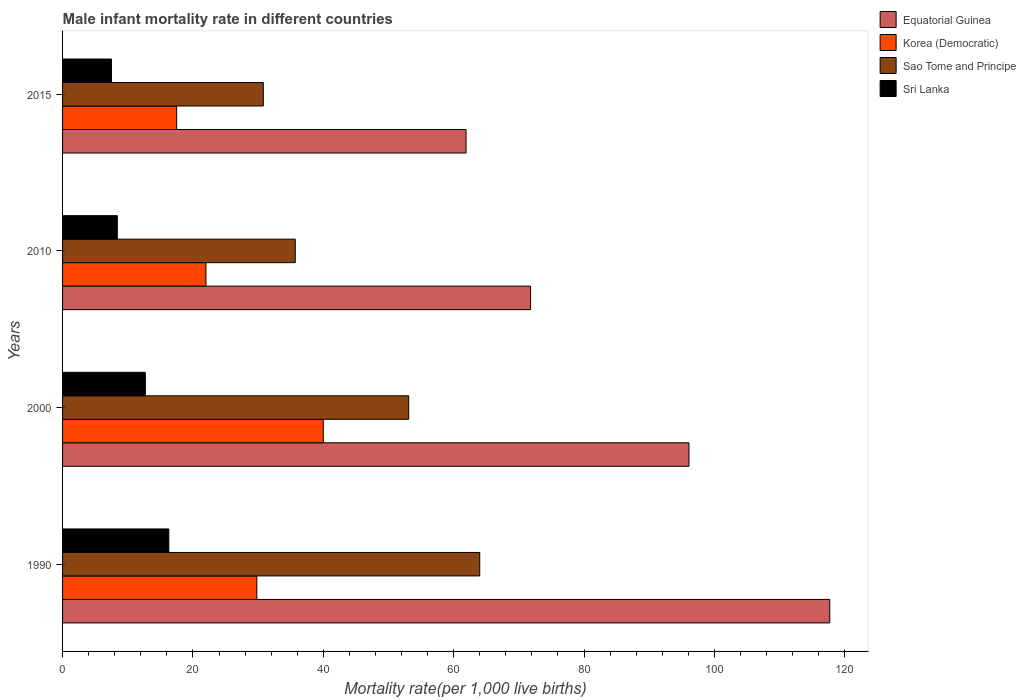How many different coloured bars are there?
Make the answer very short. 4. How many bars are there on the 3rd tick from the top?
Provide a short and direct response. 4. What is the label of the 4th group of bars from the top?
Provide a short and direct response. 1990. In how many cases, is the number of bars for a given year not equal to the number of legend labels?
Offer a terse response. 0. What is the male infant mortality rate in Equatorial Guinea in 2000?
Provide a short and direct response. 96.1. Across all years, what is the maximum male infant mortality rate in Equatorial Guinea?
Ensure brevity in your answer.  117.7. Across all years, what is the minimum male infant mortality rate in Sri Lanka?
Your response must be concise. 7.5. In which year was the male infant mortality rate in Sao Tome and Principe maximum?
Your response must be concise. 1990. In which year was the male infant mortality rate in Equatorial Guinea minimum?
Keep it short and to the point. 2015. What is the total male infant mortality rate in Sao Tome and Principe in the graph?
Offer a very short reply. 183.6. What is the difference between the male infant mortality rate in Korea (Democratic) in 2000 and that in 2015?
Keep it short and to the point. 22.5. What is the difference between the male infant mortality rate in Equatorial Guinea in 2010 and the male infant mortality rate in Sri Lanka in 2000?
Offer a very short reply. 59.1. What is the average male infant mortality rate in Sao Tome and Principe per year?
Ensure brevity in your answer.  45.9. In the year 2000, what is the difference between the male infant mortality rate in Sri Lanka and male infant mortality rate in Equatorial Guinea?
Keep it short and to the point. -83.4. What is the ratio of the male infant mortality rate in Sao Tome and Principe in 2000 to that in 2010?
Provide a short and direct response. 1.49. What is the difference between the highest and the second highest male infant mortality rate in Sri Lanka?
Offer a terse response. 3.6. What is the difference between the highest and the lowest male infant mortality rate in Equatorial Guinea?
Keep it short and to the point. 55.8. In how many years, is the male infant mortality rate in Korea (Democratic) greater than the average male infant mortality rate in Korea (Democratic) taken over all years?
Make the answer very short. 2. What does the 1st bar from the top in 2010 represents?
Provide a succinct answer. Sri Lanka. What does the 1st bar from the bottom in 2000 represents?
Provide a short and direct response. Equatorial Guinea. Is it the case that in every year, the sum of the male infant mortality rate in Sao Tome and Principe and male infant mortality rate in Equatorial Guinea is greater than the male infant mortality rate in Korea (Democratic)?
Offer a very short reply. Yes. Are all the bars in the graph horizontal?
Give a very brief answer. Yes. What is the difference between two consecutive major ticks on the X-axis?
Provide a succinct answer. 20. Are the values on the major ticks of X-axis written in scientific E-notation?
Make the answer very short. No. Does the graph contain any zero values?
Offer a terse response. No. Does the graph contain grids?
Offer a very short reply. No. How many legend labels are there?
Keep it short and to the point. 4. How are the legend labels stacked?
Your response must be concise. Vertical. What is the title of the graph?
Offer a very short reply. Male infant mortality rate in different countries. Does "Estonia" appear as one of the legend labels in the graph?
Your answer should be compact. No. What is the label or title of the X-axis?
Keep it short and to the point. Mortality rate(per 1,0 live births). What is the label or title of the Y-axis?
Offer a terse response. Years. What is the Mortality rate(per 1,000 live births) in Equatorial Guinea in 1990?
Keep it short and to the point. 117.7. What is the Mortality rate(per 1,000 live births) in Korea (Democratic) in 1990?
Provide a short and direct response. 29.8. What is the Mortality rate(per 1,000 live births) in Sao Tome and Principe in 1990?
Give a very brief answer. 64. What is the Mortality rate(per 1,000 live births) in Equatorial Guinea in 2000?
Provide a succinct answer. 96.1. What is the Mortality rate(per 1,000 live births) of Korea (Democratic) in 2000?
Give a very brief answer. 40. What is the Mortality rate(per 1,000 live births) of Sao Tome and Principe in 2000?
Keep it short and to the point. 53.1. What is the Mortality rate(per 1,000 live births) of Sri Lanka in 2000?
Offer a very short reply. 12.7. What is the Mortality rate(per 1,000 live births) of Equatorial Guinea in 2010?
Offer a very short reply. 71.8. What is the Mortality rate(per 1,000 live births) of Korea (Democratic) in 2010?
Your response must be concise. 22. What is the Mortality rate(per 1,000 live births) of Sao Tome and Principe in 2010?
Give a very brief answer. 35.7. What is the Mortality rate(per 1,000 live births) in Sri Lanka in 2010?
Make the answer very short. 8.4. What is the Mortality rate(per 1,000 live births) in Equatorial Guinea in 2015?
Offer a very short reply. 61.9. What is the Mortality rate(per 1,000 live births) of Sao Tome and Principe in 2015?
Offer a very short reply. 30.8. What is the Mortality rate(per 1,000 live births) in Sri Lanka in 2015?
Provide a short and direct response. 7.5. Across all years, what is the maximum Mortality rate(per 1,000 live births) of Equatorial Guinea?
Your response must be concise. 117.7. Across all years, what is the maximum Mortality rate(per 1,000 live births) in Korea (Democratic)?
Your response must be concise. 40. Across all years, what is the maximum Mortality rate(per 1,000 live births) in Sao Tome and Principe?
Give a very brief answer. 64. Across all years, what is the maximum Mortality rate(per 1,000 live births) in Sri Lanka?
Your answer should be compact. 16.3. Across all years, what is the minimum Mortality rate(per 1,000 live births) of Equatorial Guinea?
Provide a succinct answer. 61.9. Across all years, what is the minimum Mortality rate(per 1,000 live births) in Korea (Democratic)?
Keep it short and to the point. 17.5. Across all years, what is the minimum Mortality rate(per 1,000 live births) of Sao Tome and Principe?
Keep it short and to the point. 30.8. Across all years, what is the minimum Mortality rate(per 1,000 live births) in Sri Lanka?
Provide a succinct answer. 7.5. What is the total Mortality rate(per 1,000 live births) of Equatorial Guinea in the graph?
Make the answer very short. 347.5. What is the total Mortality rate(per 1,000 live births) in Korea (Democratic) in the graph?
Offer a terse response. 109.3. What is the total Mortality rate(per 1,000 live births) in Sao Tome and Principe in the graph?
Make the answer very short. 183.6. What is the total Mortality rate(per 1,000 live births) of Sri Lanka in the graph?
Keep it short and to the point. 44.9. What is the difference between the Mortality rate(per 1,000 live births) in Equatorial Guinea in 1990 and that in 2000?
Give a very brief answer. 21.6. What is the difference between the Mortality rate(per 1,000 live births) in Sao Tome and Principe in 1990 and that in 2000?
Make the answer very short. 10.9. What is the difference between the Mortality rate(per 1,000 live births) of Sri Lanka in 1990 and that in 2000?
Keep it short and to the point. 3.6. What is the difference between the Mortality rate(per 1,000 live births) in Equatorial Guinea in 1990 and that in 2010?
Offer a very short reply. 45.9. What is the difference between the Mortality rate(per 1,000 live births) in Korea (Democratic) in 1990 and that in 2010?
Offer a terse response. 7.8. What is the difference between the Mortality rate(per 1,000 live births) in Sao Tome and Principe in 1990 and that in 2010?
Your answer should be compact. 28.3. What is the difference between the Mortality rate(per 1,000 live births) in Sri Lanka in 1990 and that in 2010?
Your response must be concise. 7.9. What is the difference between the Mortality rate(per 1,000 live births) in Equatorial Guinea in 1990 and that in 2015?
Your response must be concise. 55.8. What is the difference between the Mortality rate(per 1,000 live births) of Korea (Democratic) in 1990 and that in 2015?
Provide a succinct answer. 12.3. What is the difference between the Mortality rate(per 1,000 live births) of Sao Tome and Principe in 1990 and that in 2015?
Your answer should be compact. 33.2. What is the difference between the Mortality rate(per 1,000 live births) of Sri Lanka in 1990 and that in 2015?
Your answer should be very brief. 8.8. What is the difference between the Mortality rate(per 1,000 live births) of Equatorial Guinea in 2000 and that in 2010?
Keep it short and to the point. 24.3. What is the difference between the Mortality rate(per 1,000 live births) in Sao Tome and Principe in 2000 and that in 2010?
Give a very brief answer. 17.4. What is the difference between the Mortality rate(per 1,000 live births) in Sri Lanka in 2000 and that in 2010?
Offer a terse response. 4.3. What is the difference between the Mortality rate(per 1,000 live births) in Equatorial Guinea in 2000 and that in 2015?
Offer a very short reply. 34.2. What is the difference between the Mortality rate(per 1,000 live births) in Korea (Democratic) in 2000 and that in 2015?
Your answer should be compact. 22.5. What is the difference between the Mortality rate(per 1,000 live births) in Sao Tome and Principe in 2000 and that in 2015?
Ensure brevity in your answer.  22.3. What is the difference between the Mortality rate(per 1,000 live births) of Equatorial Guinea in 2010 and that in 2015?
Provide a succinct answer. 9.9. What is the difference between the Mortality rate(per 1,000 live births) in Sao Tome and Principe in 2010 and that in 2015?
Your answer should be compact. 4.9. What is the difference between the Mortality rate(per 1,000 live births) of Sri Lanka in 2010 and that in 2015?
Give a very brief answer. 0.9. What is the difference between the Mortality rate(per 1,000 live births) in Equatorial Guinea in 1990 and the Mortality rate(per 1,000 live births) in Korea (Democratic) in 2000?
Your answer should be compact. 77.7. What is the difference between the Mortality rate(per 1,000 live births) of Equatorial Guinea in 1990 and the Mortality rate(per 1,000 live births) of Sao Tome and Principe in 2000?
Give a very brief answer. 64.6. What is the difference between the Mortality rate(per 1,000 live births) of Equatorial Guinea in 1990 and the Mortality rate(per 1,000 live births) of Sri Lanka in 2000?
Your answer should be compact. 105. What is the difference between the Mortality rate(per 1,000 live births) in Korea (Democratic) in 1990 and the Mortality rate(per 1,000 live births) in Sao Tome and Principe in 2000?
Offer a very short reply. -23.3. What is the difference between the Mortality rate(per 1,000 live births) of Sao Tome and Principe in 1990 and the Mortality rate(per 1,000 live births) of Sri Lanka in 2000?
Your answer should be very brief. 51.3. What is the difference between the Mortality rate(per 1,000 live births) of Equatorial Guinea in 1990 and the Mortality rate(per 1,000 live births) of Korea (Democratic) in 2010?
Your answer should be compact. 95.7. What is the difference between the Mortality rate(per 1,000 live births) of Equatorial Guinea in 1990 and the Mortality rate(per 1,000 live births) of Sri Lanka in 2010?
Your response must be concise. 109.3. What is the difference between the Mortality rate(per 1,000 live births) in Korea (Democratic) in 1990 and the Mortality rate(per 1,000 live births) in Sao Tome and Principe in 2010?
Give a very brief answer. -5.9. What is the difference between the Mortality rate(per 1,000 live births) in Korea (Democratic) in 1990 and the Mortality rate(per 1,000 live births) in Sri Lanka in 2010?
Provide a succinct answer. 21.4. What is the difference between the Mortality rate(per 1,000 live births) of Sao Tome and Principe in 1990 and the Mortality rate(per 1,000 live births) of Sri Lanka in 2010?
Provide a succinct answer. 55.6. What is the difference between the Mortality rate(per 1,000 live births) in Equatorial Guinea in 1990 and the Mortality rate(per 1,000 live births) in Korea (Democratic) in 2015?
Offer a terse response. 100.2. What is the difference between the Mortality rate(per 1,000 live births) of Equatorial Guinea in 1990 and the Mortality rate(per 1,000 live births) of Sao Tome and Principe in 2015?
Your answer should be compact. 86.9. What is the difference between the Mortality rate(per 1,000 live births) in Equatorial Guinea in 1990 and the Mortality rate(per 1,000 live births) in Sri Lanka in 2015?
Provide a succinct answer. 110.2. What is the difference between the Mortality rate(per 1,000 live births) of Korea (Democratic) in 1990 and the Mortality rate(per 1,000 live births) of Sri Lanka in 2015?
Make the answer very short. 22.3. What is the difference between the Mortality rate(per 1,000 live births) in Sao Tome and Principe in 1990 and the Mortality rate(per 1,000 live births) in Sri Lanka in 2015?
Keep it short and to the point. 56.5. What is the difference between the Mortality rate(per 1,000 live births) in Equatorial Guinea in 2000 and the Mortality rate(per 1,000 live births) in Korea (Democratic) in 2010?
Make the answer very short. 74.1. What is the difference between the Mortality rate(per 1,000 live births) in Equatorial Guinea in 2000 and the Mortality rate(per 1,000 live births) in Sao Tome and Principe in 2010?
Keep it short and to the point. 60.4. What is the difference between the Mortality rate(per 1,000 live births) in Equatorial Guinea in 2000 and the Mortality rate(per 1,000 live births) in Sri Lanka in 2010?
Your response must be concise. 87.7. What is the difference between the Mortality rate(per 1,000 live births) of Korea (Democratic) in 2000 and the Mortality rate(per 1,000 live births) of Sao Tome and Principe in 2010?
Your response must be concise. 4.3. What is the difference between the Mortality rate(per 1,000 live births) of Korea (Democratic) in 2000 and the Mortality rate(per 1,000 live births) of Sri Lanka in 2010?
Offer a very short reply. 31.6. What is the difference between the Mortality rate(per 1,000 live births) of Sao Tome and Principe in 2000 and the Mortality rate(per 1,000 live births) of Sri Lanka in 2010?
Offer a very short reply. 44.7. What is the difference between the Mortality rate(per 1,000 live births) of Equatorial Guinea in 2000 and the Mortality rate(per 1,000 live births) of Korea (Democratic) in 2015?
Offer a very short reply. 78.6. What is the difference between the Mortality rate(per 1,000 live births) in Equatorial Guinea in 2000 and the Mortality rate(per 1,000 live births) in Sao Tome and Principe in 2015?
Offer a terse response. 65.3. What is the difference between the Mortality rate(per 1,000 live births) of Equatorial Guinea in 2000 and the Mortality rate(per 1,000 live births) of Sri Lanka in 2015?
Your answer should be compact. 88.6. What is the difference between the Mortality rate(per 1,000 live births) in Korea (Democratic) in 2000 and the Mortality rate(per 1,000 live births) in Sao Tome and Principe in 2015?
Your answer should be very brief. 9.2. What is the difference between the Mortality rate(per 1,000 live births) of Korea (Democratic) in 2000 and the Mortality rate(per 1,000 live births) of Sri Lanka in 2015?
Provide a short and direct response. 32.5. What is the difference between the Mortality rate(per 1,000 live births) in Sao Tome and Principe in 2000 and the Mortality rate(per 1,000 live births) in Sri Lanka in 2015?
Ensure brevity in your answer.  45.6. What is the difference between the Mortality rate(per 1,000 live births) of Equatorial Guinea in 2010 and the Mortality rate(per 1,000 live births) of Korea (Democratic) in 2015?
Your response must be concise. 54.3. What is the difference between the Mortality rate(per 1,000 live births) in Equatorial Guinea in 2010 and the Mortality rate(per 1,000 live births) in Sao Tome and Principe in 2015?
Ensure brevity in your answer.  41. What is the difference between the Mortality rate(per 1,000 live births) of Equatorial Guinea in 2010 and the Mortality rate(per 1,000 live births) of Sri Lanka in 2015?
Your answer should be compact. 64.3. What is the difference between the Mortality rate(per 1,000 live births) of Korea (Democratic) in 2010 and the Mortality rate(per 1,000 live births) of Sri Lanka in 2015?
Offer a very short reply. 14.5. What is the difference between the Mortality rate(per 1,000 live births) of Sao Tome and Principe in 2010 and the Mortality rate(per 1,000 live births) of Sri Lanka in 2015?
Offer a terse response. 28.2. What is the average Mortality rate(per 1,000 live births) of Equatorial Guinea per year?
Your answer should be compact. 86.88. What is the average Mortality rate(per 1,000 live births) in Korea (Democratic) per year?
Provide a succinct answer. 27.32. What is the average Mortality rate(per 1,000 live births) in Sao Tome and Principe per year?
Provide a short and direct response. 45.9. What is the average Mortality rate(per 1,000 live births) of Sri Lanka per year?
Provide a short and direct response. 11.22. In the year 1990, what is the difference between the Mortality rate(per 1,000 live births) in Equatorial Guinea and Mortality rate(per 1,000 live births) in Korea (Democratic)?
Your response must be concise. 87.9. In the year 1990, what is the difference between the Mortality rate(per 1,000 live births) of Equatorial Guinea and Mortality rate(per 1,000 live births) of Sao Tome and Principe?
Provide a short and direct response. 53.7. In the year 1990, what is the difference between the Mortality rate(per 1,000 live births) of Equatorial Guinea and Mortality rate(per 1,000 live births) of Sri Lanka?
Provide a short and direct response. 101.4. In the year 1990, what is the difference between the Mortality rate(per 1,000 live births) in Korea (Democratic) and Mortality rate(per 1,000 live births) in Sao Tome and Principe?
Ensure brevity in your answer.  -34.2. In the year 1990, what is the difference between the Mortality rate(per 1,000 live births) in Korea (Democratic) and Mortality rate(per 1,000 live births) in Sri Lanka?
Your answer should be very brief. 13.5. In the year 1990, what is the difference between the Mortality rate(per 1,000 live births) in Sao Tome and Principe and Mortality rate(per 1,000 live births) in Sri Lanka?
Provide a succinct answer. 47.7. In the year 2000, what is the difference between the Mortality rate(per 1,000 live births) in Equatorial Guinea and Mortality rate(per 1,000 live births) in Korea (Democratic)?
Provide a succinct answer. 56.1. In the year 2000, what is the difference between the Mortality rate(per 1,000 live births) in Equatorial Guinea and Mortality rate(per 1,000 live births) in Sri Lanka?
Your answer should be very brief. 83.4. In the year 2000, what is the difference between the Mortality rate(per 1,000 live births) of Korea (Democratic) and Mortality rate(per 1,000 live births) of Sao Tome and Principe?
Your answer should be very brief. -13.1. In the year 2000, what is the difference between the Mortality rate(per 1,000 live births) in Korea (Democratic) and Mortality rate(per 1,000 live births) in Sri Lanka?
Provide a short and direct response. 27.3. In the year 2000, what is the difference between the Mortality rate(per 1,000 live births) of Sao Tome and Principe and Mortality rate(per 1,000 live births) of Sri Lanka?
Offer a very short reply. 40.4. In the year 2010, what is the difference between the Mortality rate(per 1,000 live births) of Equatorial Guinea and Mortality rate(per 1,000 live births) of Korea (Democratic)?
Ensure brevity in your answer.  49.8. In the year 2010, what is the difference between the Mortality rate(per 1,000 live births) of Equatorial Guinea and Mortality rate(per 1,000 live births) of Sao Tome and Principe?
Ensure brevity in your answer.  36.1. In the year 2010, what is the difference between the Mortality rate(per 1,000 live births) of Equatorial Guinea and Mortality rate(per 1,000 live births) of Sri Lanka?
Your answer should be compact. 63.4. In the year 2010, what is the difference between the Mortality rate(per 1,000 live births) of Korea (Democratic) and Mortality rate(per 1,000 live births) of Sao Tome and Principe?
Your response must be concise. -13.7. In the year 2010, what is the difference between the Mortality rate(per 1,000 live births) in Sao Tome and Principe and Mortality rate(per 1,000 live births) in Sri Lanka?
Offer a very short reply. 27.3. In the year 2015, what is the difference between the Mortality rate(per 1,000 live births) of Equatorial Guinea and Mortality rate(per 1,000 live births) of Korea (Democratic)?
Ensure brevity in your answer.  44.4. In the year 2015, what is the difference between the Mortality rate(per 1,000 live births) of Equatorial Guinea and Mortality rate(per 1,000 live births) of Sao Tome and Principe?
Offer a terse response. 31.1. In the year 2015, what is the difference between the Mortality rate(per 1,000 live births) in Equatorial Guinea and Mortality rate(per 1,000 live births) in Sri Lanka?
Offer a very short reply. 54.4. In the year 2015, what is the difference between the Mortality rate(per 1,000 live births) in Korea (Democratic) and Mortality rate(per 1,000 live births) in Sao Tome and Principe?
Give a very brief answer. -13.3. In the year 2015, what is the difference between the Mortality rate(per 1,000 live births) of Korea (Democratic) and Mortality rate(per 1,000 live births) of Sri Lanka?
Ensure brevity in your answer.  10. In the year 2015, what is the difference between the Mortality rate(per 1,000 live births) of Sao Tome and Principe and Mortality rate(per 1,000 live births) of Sri Lanka?
Your answer should be compact. 23.3. What is the ratio of the Mortality rate(per 1,000 live births) in Equatorial Guinea in 1990 to that in 2000?
Provide a succinct answer. 1.22. What is the ratio of the Mortality rate(per 1,000 live births) of Korea (Democratic) in 1990 to that in 2000?
Offer a terse response. 0.74. What is the ratio of the Mortality rate(per 1,000 live births) in Sao Tome and Principe in 1990 to that in 2000?
Ensure brevity in your answer.  1.21. What is the ratio of the Mortality rate(per 1,000 live births) of Sri Lanka in 1990 to that in 2000?
Give a very brief answer. 1.28. What is the ratio of the Mortality rate(per 1,000 live births) of Equatorial Guinea in 1990 to that in 2010?
Provide a short and direct response. 1.64. What is the ratio of the Mortality rate(per 1,000 live births) in Korea (Democratic) in 1990 to that in 2010?
Your response must be concise. 1.35. What is the ratio of the Mortality rate(per 1,000 live births) of Sao Tome and Principe in 1990 to that in 2010?
Your response must be concise. 1.79. What is the ratio of the Mortality rate(per 1,000 live births) in Sri Lanka in 1990 to that in 2010?
Keep it short and to the point. 1.94. What is the ratio of the Mortality rate(per 1,000 live births) of Equatorial Guinea in 1990 to that in 2015?
Offer a very short reply. 1.9. What is the ratio of the Mortality rate(per 1,000 live births) of Korea (Democratic) in 1990 to that in 2015?
Your response must be concise. 1.7. What is the ratio of the Mortality rate(per 1,000 live births) of Sao Tome and Principe in 1990 to that in 2015?
Your answer should be compact. 2.08. What is the ratio of the Mortality rate(per 1,000 live births) in Sri Lanka in 1990 to that in 2015?
Make the answer very short. 2.17. What is the ratio of the Mortality rate(per 1,000 live births) in Equatorial Guinea in 2000 to that in 2010?
Your response must be concise. 1.34. What is the ratio of the Mortality rate(per 1,000 live births) in Korea (Democratic) in 2000 to that in 2010?
Provide a short and direct response. 1.82. What is the ratio of the Mortality rate(per 1,000 live births) in Sao Tome and Principe in 2000 to that in 2010?
Make the answer very short. 1.49. What is the ratio of the Mortality rate(per 1,000 live births) of Sri Lanka in 2000 to that in 2010?
Provide a succinct answer. 1.51. What is the ratio of the Mortality rate(per 1,000 live births) of Equatorial Guinea in 2000 to that in 2015?
Offer a terse response. 1.55. What is the ratio of the Mortality rate(per 1,000 live births) in Korea (Democratic) in 2000 to that in 2015?
Give a very brief answer. 2.29. What is the ratio of the Mortality rate(per 1,000 live births) of Sao Tome and Principe in 2000 to that in 2015?
Your response must be concise. 1.72. What is the ratio of the Mortality rate(per 1,000 live births) of Sri Lanka in 2000 to that in 2015?
Your answer should be very brief. 1.69. What is the ratio of the Mortality rate(per 1,000 live births) in Equatorial Guinea in 2010 to that in 2015?
Your response must be concise. 1.16. What is the ratio of the Mortality rate(per 1,000 live births) in Korea (Democratic) in 2010 to that in 2015?
Offer a very short reply. 1.26. What is the ratio of the Mortality rate(per 1,000 live births) in Sao Tome and Principe in 2010 to that in 2015?
Offer a terse response. 1.16. What is the ratio of the Mortality rate(per 1,000 live births) in Sri Lanka in 2010 to that in 2015?
Make the answer very short. 1.12. What is the difference between the highest and the second highest Mortality rate(per 1,000 live births) of Equatorial Guinea?
Ensure brevity in your answer.  21.6. What is the difference between the highest and the second highest Mortality rate(per 1,000 live births) in Korea (Democratic)?
Offer a terse response. 10.2. What is the difference between the highest and the second highest Mortality rate(per 1,000 live births) in Sri Lanka?
Make the answer very short. 3.6. What is the difference between the highest and the lowest Mortality rate(per 1,000 live births) of Equatorial Guinea?
Ensure brevity in your answer.  55.8. What is the difference between the highest and the lowest Mortality rate(per 1,000 live births) in Sao Tome and Principe?
Offer a very short reply. 33.2. 